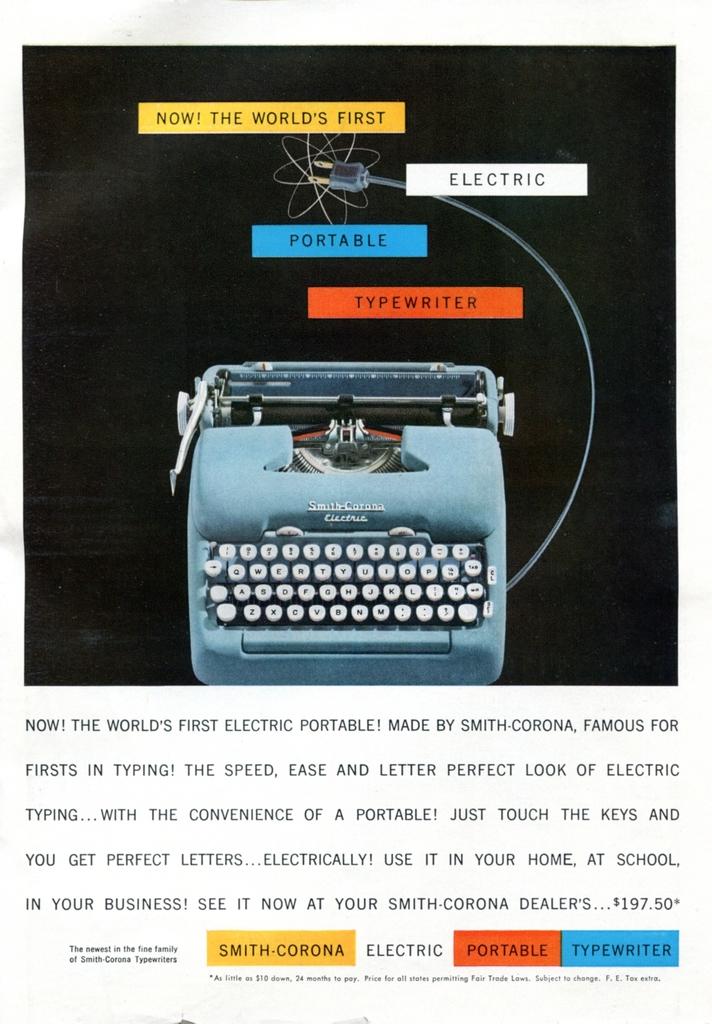What company made this typewriter?
Keep it short and to the point. Smith-corona. What is being advertised?
Keep it short and to the point. Electric portable typewriter. 